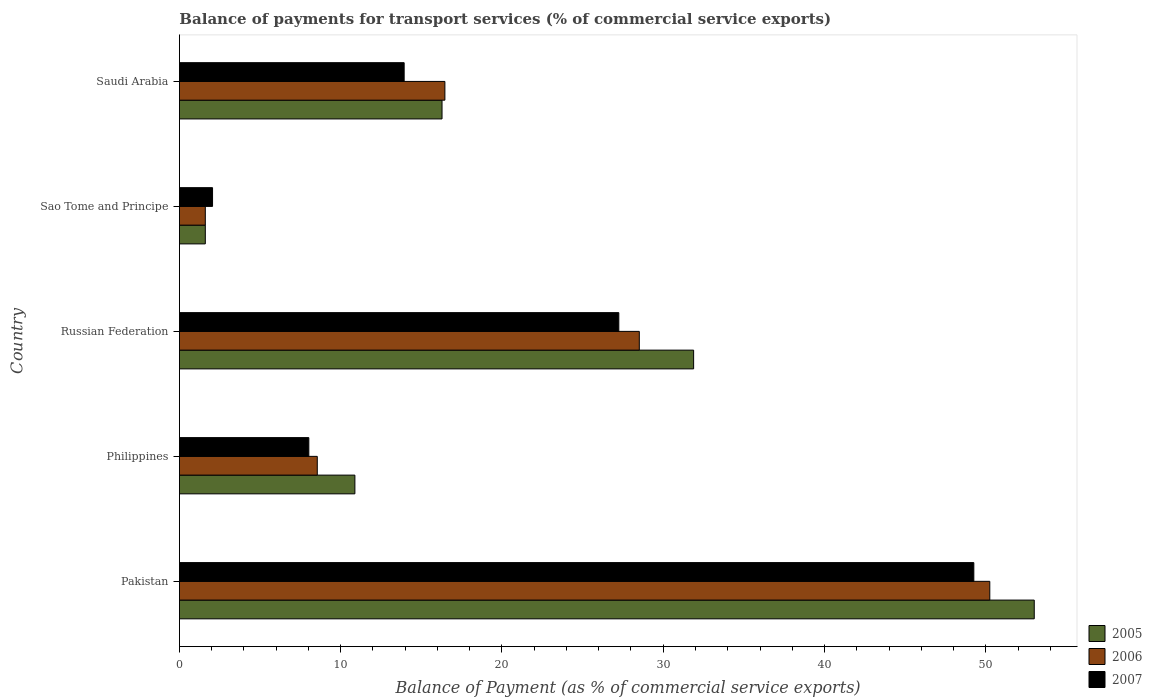How many groups of bars are there?
Your response must be concise. 5. How many bars are there on the 1st tick from the top?
Offer a terse response. 3. How many bars are there on the 5th tick from the bottom?
Your answer should be compact. 3. In how many cases, is the number of bars for a given country not equal to the number of legend labels?
Your response must be concise. 0. What is the balance of payments for transport services in 2006 in Saudi Arabia?
Offer a terse response. 16.46. Across all countries, what is the maximum balance of payments for transport services in 2007?
Offer a very short reply. 49.26. Across all countries, what is the minimum balance of payments for transport services in 2007?
Your response must be concise. 2.05. In which country was the balance of payments for transport services in 2007 minimum?
Your response must be concise. Sao Tome and Principe. What is the total balance of payments for transport services in 2006 in the graph?
Your response must be concise. 105.38. What is the difference between the balance of payments for transport services in 2005 in Pakistan and that in Russian Federation?
Offer a very short reply. 21.12. What is the difference between the balance of payments for transport services in 2005 in Philippines and the balance of payments for transport services in 2007 in Pakistan?
Offer a terse response. -38.38. What is the average balance of payments for transport services in 2007 per country?
Keep it short and to the point. 20.1. What is the difference between the balance of payments for transport services in 2007 and balance of payments for transport services in 2006 in Saudi Arabia?
Provide a succinct answer. -2.53. What is the ratio of the balance of payments for transport services in 2007 in Pakistan to that in Russian Federation?
Provide a short and direct response. 1.81. Is the difference between the balance of payments for transport services in 2007 in Sao Tome and Principe and Saudi Arabia greater than the difference between the balance of payments for transport services in 2006 in Sao Tome and Principe and Saudi Arabia?
Ensure brevity in your answer.  Yes. What is the difference between the highest and the second highest balance of payments for transport services in 2007?
Keep it short and to the point. 22.01. What is the difference between the highest and the lowest balance of payments for transport services in 2005?
Keep it short and to the point. 51.4. Is it the case that in every country, the sum of the balance of payments for transport services in 2006 and balance of payments for transport services in 2007 is greater than the balance of payments for transport services in 2005?
Your answer should be compact. Yes. How many countries are there in the graph?
Give a very brief answer. 5. What is the difference between two consecutive major ticks on the X-axis?
Your answer should be compact. 10. Are the values on the major ticks of X-axis written in scientific E-notation?
Provide a succinct answer. No. Where does the legend appear in the graph?
Your response must be concise. Bottom right. How many legend labels are there?
Offer a terse response. 3. What is the title of the graph?
Your response must be concise. Balance of payments for transport services (% of commercial service exports). Does "1997" appear as one of the legend labels in the graph?
Your answer should be compact. No. What is the label or title of the X-axis?
Offer a terse response. Balance of Payment (as % of commercial service exports). What is the label or title of the Y-axis?
Provide a succinct answer. Country. What is the Balance of Payment (as % of commercial service exports) of 2005 in Pakistan?
Your answer should be very brief. 53. What is the Balance of Payment (as % of commercial service exports) of 2006 in Pakistan?
Give a very brief answer. 50.25. What is the Balance of Payment (as % of commercial service exports) in 2007 in Pakistan?
Make the answer very short. 49.26. What is the Balance of Payment (as % of commercial service exports) in 2005 in Philippines?
Offer a very short reply. 10.88. What is the Balance of Payment (as % of commercial service exports) in 2006 in Philippines?
Ensure brevity in your answer.  8.55. What is the Balance of Payment (as % of commercial service exports) in 2007 in Philippines?
Give a very brief answer. 8.02. What is the Balance of Payment (as % of commercial service exports) of 2005 in Russian Federation?
Your answer should be compact. 31.88. What is the Balance of Payment (as % of commercial service exports) of 2006 in Russian Federation?
Keep it short and to the point. 28.52. What is the Balance of Payment (as % of commercial service exports) in 2007 in Russian Federation?
Offer a very short reply. 27.25. What is the Balance of Payment (as % of commercial service exports) in 2005 in Sao Tome and Principe?
Ensure brevity in your answer.  1.61. What is the Balance of Payment (as % of commercial service exports) in 2006 in Sao Tome and Principe?
Provide a short and direct response. 1.61. What is the Balance of Payment (as % of commercial service exports) in 2007 in Sao Tome and Principe?
Your answer should be very brief. 2.05. What is the Balance of Payment (as % of commercial service exports) in 2005 in Saudi Arabia?
Offer a very short reply. 16.28. What is the Balance of Payment (as % of commercial service exports) of 2006 in Saudi Arabia?
Your answer should be very brief. 16.46. What is the Balance of Payment (as % of commercial service exports) of 2007 in Saudi Arabia?
Ensure brevity in your answer.  13.94. Across all countries, what is the maximum Balance of Payment (as % of commercial service exports) of 2005?
Your answer should be compact. 53. Across all countries, what is the maximum Balance of Payment (as % of commercial service exports) of 2006?
Provide a succinct answer. 50.25. Across all countries, what is the maximum Balance of Payment (as % of commercial service exports) of 2007?
Keep it short and to the point. 49.26. Across all countries, what is the minimum Balance of Payment (as % of commercial service exports) in 2005?
Give a very brief answer. 1.61. Across all countries, what is the minimum Balance of Payment (as % of commercial service exports) of 2006?
Your answer should be very brief. 1.61. Across all countries, what is the minimum Balance of Payment (as % of commercial service exports) of 2007?
Make the answer very short. 2.05. What is the total Balance of Payment (as % of commercial service exports) in 2005 in the graph?
Offer a terse response. 113.66. What is the total Balance of Payment (as % of commercial service exports) in 2006 in the graph?
Give a very brief answer. 105.38. What is the total Balance of Payment (as % of commercial service exports) in 2007 in the graph?
Offer a very short reply. 100.52. What is the difference between the Balance of Payment (as % of commercial service exports) of 2005 in Pakistan and that in Philippines?
Offer a terse response. 42.12. What is the difference between the Balance of Payment (as % of commercial service exports) of 2006 in Pakistan and that in Philippines?
Provide a succinct answer. 41.7. What is the difference between the Balance of Payment (as % of commercial service exports) in 2007 in Pakistan and that in Philippines?
Offer a very short reply. 41.23. What is the difference between the Balance of Payment (as % of commercial service exports) of 2005 in Pakistan and that in Russian Federation?
Offer a very short reply. 21.12. What is the difference between the Balance of Payment (as % of commercial service exports) of 2006 in Pakistan and that in Russian Federation?
Offer a very short reply. 21.73. What is the difference between the Balance of Payment (as % of commercial service exports) in 2007 in Pakistan and that in Russian Federation?
Keep it short and to the point. 22.01. What is the difference between the Balance of Payment (as % of commercial service exports) of 2005 in Pakistan and that in Sao Tome and Principe?
Your answer should be very brief. 51.4. What is the difference between the Balance of Payment (as % of commercial service exports) in 2006 in Pakistan and that in Sao Tome and Principe?
Your response must be concise. 48.64. What is the difference between the Balance of Payment (as % of commercial service exports) of 2007 in Pakistan and that in Sao Tome and Principe?
Provide a succinct answer. 47.2. What is the difference between the Balance of Payment (as % of commercial service exports) in 2005 in Pakistan and that in Saudi Arabia?
Your response must be concise. 36.72. What is the difference between the Balance of Payment (as % of commercial service exports) in 2006 in Pakistan and that in Saudi Arabia?
Provide a short and direct response. 33.79. What is the difference between the Balance of Payment (as % of commercial service exports) of 2007 in Pakistan and that in Saudi Arabia?
Make the answer very short. 35.32. What is the difference between the Balance of Payment (as % of commercial service exports) of 2005 in Philippines and that in Russian Federation?
Your answer should be very brief. -21. What is the difference between the Balance of Payment (as % of commercial service exports) in 2006 in Philippines and that in Russian Federation?
Keep it short and to the point. -19.97. What is the difference between the Balance of Payment (as % of commercial service exports) of 2007 in Philippines and that in Russian Federation?
Make the answer very short. -19.22. What is the difference between the Balance of Payment (as % of commercial service exports) in 2005 in Philippines and that in Sao Tome and Principe?
Your answer should be very brief. 9.28. What is the difference between the Balance of Payment (as % of commercial service exports) in 2006 in Philippines and that in Sao Tome and Principe?
Provide a succinct answer. 6.94. What is the difference between the Balance of Payment (as % of commercial service exports) of 2007 in Philippines and that in Sao Tome and Principe?
Offer a very short reply. 5.97. What is the difference between the Balance of Payment (as % of commercial service exports) in 2005 in Philippines and that in Saudi Arabia?
Your response must be concise. -5.4. What is the difference between the Balance of Payment (as % of commercial service exports) in 2006 in Philippines and that in Saudi Arabia?
Keep it short and to the point. -7.91. What is the difference between the Balance of Payment (as % of commercial service exports) of 2007 in Philippines and that in Saudi Arabia?
Provide a succinct answer. -5.91. What is the difference between the Balance of Payment (as % of commercial service exports) of 2005 in Russian Federation and that in Sao Tome and Principe?
Provide a succinct answer. 30.28. What is the difference between the Balance of Payment (as % of commercial service exports) of 2006 in Russian Federation and that in Sao Tome and Principe?
Make the answer very short. 26.91. What is the difference between the Balance of Payment (as % of commercial service exports) in 2007 in Russian Federation and that in Sao Tome and Principe?
Your answer should be very brief. 25.19. What is the difference between the Balance of Payment (as % of commercial service exports) of 2005 in Russian Federation and that in Saudi Arabia?
Make the answer very short. 15.6. What is the difference between the Balance of Payment (as % of commercial service exports) in 2006 in Russian Federation and that in Saudi Arabia?
Give a very brief answer. 12.05. What is the difference between the Balance of Payment (as % of commercial service exports) in 2007 in Russian Federation and that in Saudi Arabia?
Give a very brief answer. 13.31. What is the difference between the Balance of Payment (as % of commercial service exports) of 2005 in Sao Tome and Principe and that in Saudi Arabia?
Offer a very short reply. -14.68. What is the difference between the Balance of Payment (as % of commercial service exports) in 2006 in Sao Tome and Principe and that in Saudi Arabia?
Your answer should be very brief. -14.86. What is the difference between the Balance of Payment (as % of commercial service exports) in 2007 in Sao Tome and Principe and that in Saudi Arabia?
Ensure brevity in your answer.  -11.88. What is the difference between the Balance of Payment (as % of commercial service exports) in 2005 in Pakistan and the Balance of Payment (as % of commercial service exports) in 2006 in Philippines?
Provide a short and direct response. 44.46. What is the difference between the Balance of Payment (as % of commercial service exports) in 2005 in Pakistan and the Balance of Payment (as % of commercial service exports) in 2007 in Philippines?
Give a very brief answer. 44.98. What is the difference between the Balance of Payment (as % of commercial service exports) in 2006 in Pakistan and the Balance of Payment (as % of commercial service exports) in 2007 in Philippines?
Offer a very short reply. 42.22. What is the difference between the Balance of Payment (as % of commercial service exports) in 2005 in Pakistan and the Balance of Payment (as % of commercial service exports) in 2006 in Russian Federation?
Give a very brief answer. 24.49. What is the difference between the Balance of Payment (as % of commercial service exports) of 2005 in Pakistan and the Balance of Payment (as % of commercial service exports) of 2007 in Russian Federation?
Your answer should be compact. 25.76. What is the difference between the Balance of Payment (as % of commercial service exports) of 2006 in Pakistan and the Balance of Payment (as % of commercial service exports) of 2007 in Russian Federation?
Make the answer very short. 23. What is the difference between the Balance of Payment (as % of commercial service exports) of 2005 in Pakistan and the Balance of Payment (as % of commercial service exports) of 2006 in Sao Tome and Principe?
Keep it short and to the point. 51.4. What is the difference between the Balance of Payment (as % of commercial service exports) in 2005 in Pakistan and the Balance of Payment (as % of commercial service exports) in 2007 in Sao Tome and Principe?
Offer a terse response. 50.95. What is the difference between the Balance of Payment (as % of commercial service exports) of 2006 in Pakistan and the Balance of Payment (as % of commercial service exports) of 2007 in Sao Tome and Principe?
Provide a short and direct response. 48.19. What is the difference between the Balance of Payment (as % of commercial service exports) of 2005 in Pakistan and the Balance of Payment (as % of commercial service exports) of 2006 in Saudi Arabia?
Keep it short and to the point. 36.54. What is the difference between the Balance of Payment (as % of commercial service exports) of 2005 in Pakistan and the Balance of Payment (as % of commercial service exports) of 2007 in Saudi Arabia?
Your response must be concise. 39.07. What is the difference between the Balance of Payment (as % of commercial service exports) of 2006 in Pakistan and the Balance of Payment (as % of commercial service exports) of 2007 in Saudi Arabia?
Provide a succinct answer. 36.31. What is the difference between the Balance of Payment (as % of commercial service exports) in 2005 in Philippines and the Balance of Payment (as % of commercial service exports) in 2006 in Russian Federation?
Your answer should be very brief. -17.64. What is the difference between the Balance of Payment (as % of commercial service exports) of 2005 in Philippines and the Balance of Payment (as % of commercial service exports) of 2007 in Russian Federation?
Your answer should be compact. -16.36. What is the difference between the Balance of Payment (as % of commercial service exports) in 2006 in Philippines and the Balance of Payment (as % of commercial service exports) in 2007 in Russian Federation?
Provide a succinct answer. -18.7. What is the difference between the Balance of Payment (as % of commercial service exports) of 2005 in Philippines and the Balance of Payment (as % of commercial service exports) of 2006 in Sao Tome and Principe?
Provide a succinct answer. 9.28. What is the difference between the Balance of Payment (as % of commercial service exports) of 2005 in Philippines and the Balance of Payment (as % of commercial service exports) of 2007 in Sao Tome and Principe?
Your response must be concise. 8.83. What is the difference between the Balance of Payment (as % of commercial service exports) in 2006 in Philippines and the Balance of Payment (as % of commercial service exports) in 2007 in Sao Tome and Principe?
Make the answer very short. 6.49. What is the difference between the Balance of Payment (as % of commercial service exports) of 2005 in Philippines and the Balance of Payment (as % of commercial service exports) of 2006 in Saudi Arabia?
Provide a short and direct response. -5.58. What is the difference between the Balance of Payment (as % of commercial service exports) in 2005 in Philippines and the Balance of Payment (as % of commercial service exports) in 2007 in Saudi Arabia?
Ensure brevity in your answer.  -3.05. What is the difference between the Balance of Payment (as % of commercial service exports) in 2006 in Philippines and the Balance of Payment (as % of commercial service exports) in 2007 in Saudi Arabia?
Your answer should be compact. -5.39. What is the difference between the Balance of Payment (as % of commercial service exports) of 2005 in Russian Federation and the Balance of Payment (as % of commercial service exports) of 2006 in Sao Tome and Principe?
Ensure brevity in your answer.  30.28. What is the difference between the Balance of Payment (as % of commercial service exports) in 2005 in Russian Federation and the Balance of Payment (as % of commercial service exports) in 2007 in Sao Tome and Principe?
Your response must be concise. 29.83. What is the difference between the Balance of Payment (as % of commercial service exports) of 2006 in Russian Federation and the Balance of Payment (as % of commercial service exports) of 2007 in Sao Tome and Principe?
Your response must be concise. 26.46. What is the difference between the Balance of Payment (as % of commercial service exports) in 2005 in Russian Federation and the Balance of Payment (as % of commercial service exports) in 2006 in Saudi Arabia?
Keep it short and to the point. 15.42. What is the difference between the Balance of Payment (as % of commercial service exports) in 2005 in Russian Federation and the Balance of Payment (as % of commercial service exports) in 2007 in Saudi Arabia?
Provide a short and direct response. 17.95. What is the difference between the Balance of Payment (as % of commercial service exports) in 2006 in Russian Federation and the Balance of Payment (as % of commercial service exports) in 2007 in Saudi Arabia?
Your answer should be compact. 14.58. What is the difference between the Balance of Payment (as % of commercial service exports) of 2005 in Sao Tome and Principe and the Balance of Payment (as % of commercial service exports) of 2006 in Saudi Arabia?
Provide a short and direct response. -14.86. What is the difference between the Balance of Payment (as % of commercial service exports) of 2005 in Sao Tome and Principe and the Balance of Payment (as % of commercial service exports) of 2007 in Saudi Arabia?
Keep it short and to the point. -12.33. What is the difference between the Balance of Payment (as % of commercial service exports) of 2006 in Sao Tome and Principe and the Balance of Payment (as % of commercial service exports) of 2007 in Saudi Arabia?
Your answer should be very brief. -12.33. What is the average Balance of Payment (as % of commercial service exports) of 2005 per country?
Give a very brief answer. 22.73. What is the average Balance of Payment (as % of commercial service exports) in 2006 per country?
Keep it short and to the point. 21.08. What is the average Balance of Payment (as % of commercial service exports) in 2007 per country?
Give a very brief answer. 20.1. What is the difference between the Balance of Payment (as % of commercial service exports) in 2005 and Balance of Payment (as % of commercial service exports) in 2006 in Pakistan?
Give a very brief answer. 2.76. What is the difference between the Balance of Payment (as % of commercial service exports) in 2005 and Balance of Payment (as % of commercial service exports) in 2007 in Pakistan?
Offer a terse response. 3.75. What is the difference between the Balance of Payment (as % of commercial service exports) in 2005 and Balance of Payment (as % of commercial service exports) in 2006 in Philippines?
Keep it short and to the point. 2.33. What is the difference between the Balance of Payment (as % of commercial service exports) in 2005 and Balance of Payment (as % of commercial service exports) in 2007 in Philippines?
Your answer should be compact. 2.86. What is the difference between the Balance of Payment (as % of commercial service exports) in 2006 and Balance of Payment (as % of commercial service exports) in 2007 in Philippines?
Offer a very short reply. 0.52. What is the difference between the Balance of Payment (as % of commercial service exports) of 2005 and Balance of Payment (as % of commercial service exports) of 2006 in Russian Federation?
Ensure brevity in your answer.  3.37. What is the difference between the Balance of Payment (as % of commercial service exports) of 2005 and Balance of Payment (as % of commercial service exports) of 2007 in Russian Federation?
Ensure brevity in your answer.  4.64. What is the difference between the Balance of Payment (as % of commercial service exports) in 2006 and Balance of Payment (as % of commercial service exports) in 2007 in Russian Federation?
Provide a short and direct response. 1.27. What is the difference between the Balance of Payment (as % of commercial service exports) in 2005 and Balance of Payment (as % of commercial service exports) in 2006 in Sao Tome and Principe?
Provide a succinct answer. 0. What is the difference between the Balance of Payment (as % of commercial service exports) in 2005 and Balance of Payment (as % of commercial service exports) in 2007 in Sao Tome and Principe?
Your answer should be very brief. -0.45. What is the difference between the Balance of Payment (as % of commercial service exports) in 2006 and Balance of Payment (as % of commercial service exports) in 2007 in Sao Tome and Principe?
Your response must be concise. -0.45. What is the difference between the Balance of Payment (as % of commercial service exports) in 2005 and Balance of Payment (as % of commercial service exports) in 2006 in Saudi Arabia?
Your answer should be very brief. -0.18. What is the difference between the Balance of Payment (as % of commercial service exports) in 2005 and Balance of Payment (as % of commercial service exports) in 2007 in Saudi Arabia?
Provide a succinct answer. 2.35. What is the difference between the Balance of Payment (as % of commercial service exports) of 2006 and Balance of Payment (as % of commercial service exports) of 2007 in Saudi Arabia?
Provide a succinct answer. 2.53. What is the ratio of the Balance of Payment (as % of commercial service exports) in 2005 in Pakistan to that in Philippines?
Your answer should be very brief. 4.87. What is the ratio of the Balance of Payment (as % of commercial service exports) in 2006 in Pakistan to that in Philippines?
Your answer should be compact. 5.88. What is the ratio of the Balance of Payment (as % of commercial service exports) of 2007 in Pakistan to that in Philippines?
Keep it short and to the point. 6.14. What is the ratio of the Balance of Payment (as % of commercial service exports) in 2005 in Pakistan to that in Russian Federation?
Your answer should be very brief. 1.66. What is the ratio of the Balance of Payment (as % of commercial service exports) of 2006 in Pakistan to that in Russian Federation?
Offer a terse response. 1.76. What is the ratio of the Balance of Payment (as % of commercial service exports) of 2007 in Pakistan to that in Russian Federation?
Ensure brevity in your answer.  1.81. What is the ratio of the Balance of Payment (as % of commercial service exports) of 2005 in Pakistan to that in Sao Tome and Principe?
Your answer should be very brief. 33.02. What is the ratio of the Balance of Payment (as % of commercial service exports) of 2006 in Pakistan to that in Sao Tome and Principe?
Offer a very short reply. 31.3. What is the ratio of the Balance of Payment (as % of commercial service exports) of 2007 in Pakistan to that in Sao Tome and Principe?
Provide a succinct answer. 23.97. What is the ratio of the Balance of Payment (as % of commercial service exports) in 2005 in Pakistan to that in Saudi Arabia?
Make the answer very short. 3.26. What is the ratio of the Balance of Payment (as % of commercial service exports) of 2006 in Pakistan to that in Saudi Arabia?
Provide a short and direct response. 3.05. What is the ratio of the Balance of Payment (as % of commercial service exports) in 2007 in Pakistan to that in Saudi Arabia?
Offer a terse response. 3.53. What is the ratio of the Balance of Payment (as % of commercial service exports) in 2005 in Philippines to that in Russian Federation?
Keep it short and to the point. 0.34. What is the ratio of the Balance of Payment (as % of commercial service exports) in 2006 in Philippines to that in Russian Federation?
Your response must be concise. 0.3. What is the ratio of the Balance of Payment (as % of commercial service exports) in 2007 in Philippines to that in Russian Federation?
Your answer should be very brief. 0.29. What is the ratio of the Balance of Payment (as % of commercial service exports) in 2005 in Philippines to that in Sao Tome and Principe?
Ensure brevity in your answer.  6.78. What is the ratio of the Balance of Payment (as % of commercial service exports) of 2006 in Philippines to that in Sao Tome and Principe?
Keep it short and to the point. 5.32. What is the ratio of the Balance of Payment (as % of commercial service exports) of 2007 in Philippines to that in Sao Tome and Principe?
Keep it short and to the point. 3.91. What is the ratio of the Balance of Payment (as % of commercial service exports) of 2005 in Philippines to that in Saudi Arabia?
Provide a short and direct response. 0.67. What is the ratio of the Balance of Payment (as % of commercial service exports) of 2006 in Philippines to that in Saudi Arabia?
Offer a terse response. 0.52. What is the ratio of the Balance of Payment (as % of commercial service exports) in 2007 in Philippines to that in Saudi Arabia?
Your response must be concise. 0.58. What is the ratio of the Balance of Payment (as % of commercial service exports) in 2005 in Russian Federation to that in Sao Tome and Principe?
Give a very brief answer. 19.86. What is the ratio of the Balance of Payment (as % of commercial service exports) of 2006 in Russian Federation to that in Sao Tome and Principe?
Offer a terse response. 17.76. What is the ratio of the Balance of Payment (as % of commercial service exports) of 2007 in Russian Federation to that in Sao Tome and Principe?
Ensure brevity in your answer.  13.26. What is the ratio of the Balance of Payment (as % of commercial service exports) in 2005 in Russian Federation to that in Saudi Arabia?
Make the answer very short. 1.96. What is the ratio of the Balance of Payment (as % of commercial service exports) in 2006 in Russian Federation to that in Saudi Arabia?
Keep it short and to the point. 1.73. What is the ratio of the Balance of Payment (as % of commercial service exports) of 2007 in Russian Federation to that in Saudi Arabia?
Your answer should be very brief. 1.96. What is the ratio of the Balance of Payment (as % of commercial service exports) in 2005 in Sao Tome and Principe to that in Saudi Arabia?
Your answer should be compact. 0.1. What is the ratio of the Balance of Payment (as % of commercial service exports) of 2006 in Sao Tome and Principe to that in Saudi Arabia?
Offer a very short reply. 0.1. What is the ratio of the Balance of Payment (as % of commercial service exports) of 2007 in Sao Tome and Principe to that in Saudi Arabia?
Offer a terse response. 0.15. What is the difference between the highest and the second highest Balance of Payment (as % of commercial service exports) in 2005?
Ensure brevity in your answer.  21.12. What is the difference between the highest and the second highest Balance of Payment (as % of commercial service exports) in 2006?
Offer a terse response. 21.73. What is the difference between the highest and the second highest Balance of Payment (as % of commercial service exports) of 2007?
Make the answer very short. 22.01. What is the difference between the highest and the lowest Balance of Payment (as % of commercial service exports) in 2005?
Ensure brevity in your answer.  51.4. What is the difference between the highest and the lowest Balance of Payment (as % of commercial service exports) in 2006?
Make the answer very short. 48.64. What is the difference between the highest and the lowest Balance of Payment (as % of commercial service exports) in 2007?
Your response must be concise. 47.2. 